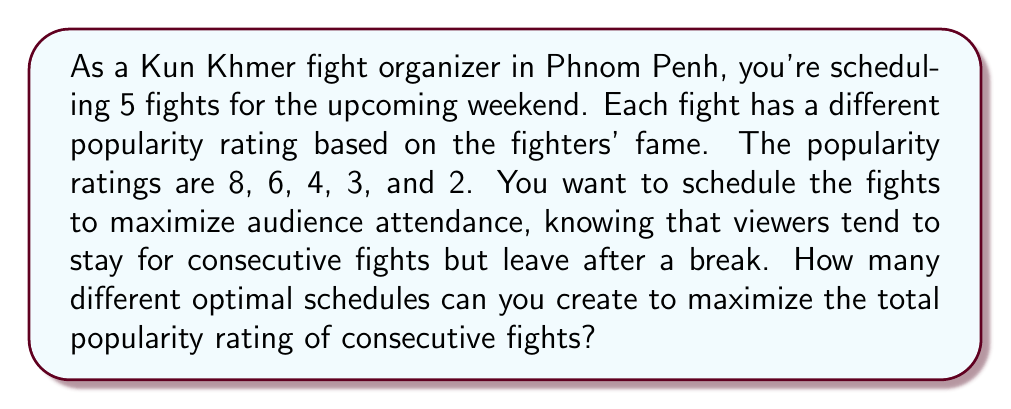Can you solve this math problem? To solve this problem, we can use concepts from graph theory, specifically the idea of finding the longest path in a directed acyclic graph (DAG).

1) First, let's represent each fight as a vertex in our graph, with the popularity rating as the vertex weight.

2) We'll create edges between vertices to represent possible consecutive fights. Since any fight can follow another, we'll have edges between all pairs of vertices.

3) Our goal is to find the longest path in this graph, where the length of the path is the sum of the vertex weights.

4) In graph theory, this problem is equivalent to finding the maximum weight independent set in the complement of the graph.

5) For a graph with $n$ vertices, the number of maximum weight independent sets is equal to the $n$-th Fibonacci number in many cases.

6) In our case, with 5 vertices, we need to find the 5th Fibonacci number.

7) The Fibonacci sequence starts with 1, 1, and each subsequent number is the sum of the two preceding ones: 1, 1, 2, 3, 5, ...

8) Therefore, the 5th Fibonacci number is 5.

This means there are 5 different ways to schedule the fights to maximize the total popularity rating of consecutive fights.

Each of these 5 optimal schedules will include the fights with popularity ratings 8 and 6, as these are the two highest-rated fights and will always be included in an optimal solution.
Answer: There are 5 different optimal schedules that maximize the total popularity rating of consecutive fights. 